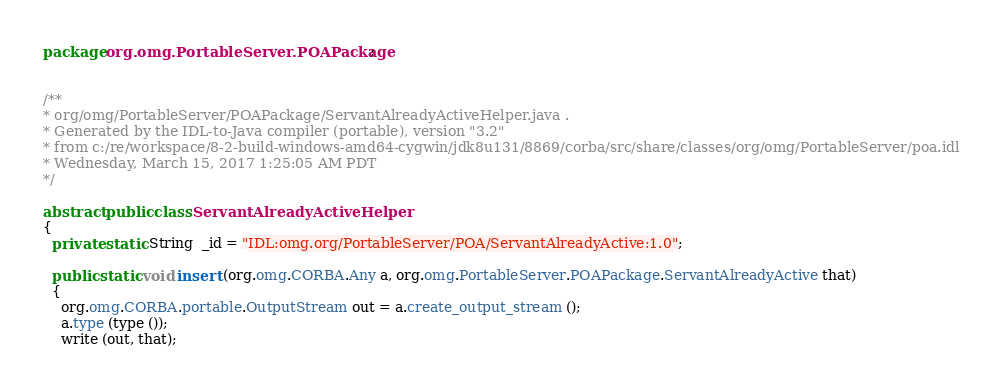Convert code to text. <code><loc_0><loc_0><loc_500><loc_500><_Java_>package org.omg.PortableServer.POAPackage;


/**
* org/omg/PortableServer/POAPackage/ServantAlreadyActiveHelper.java .
* Generated by the IDL-to-Java compiler (portable), version "3.2"
* from c:/re/workspace/8-2-build-windows-amd64-cygwin/jdk8u131/8869/corba/src/share/classes/org/omg/PortableServer/poa.idl
* Wednesday, March 15, 2017 1:25:05 AM PDT
*/

abstract public class ServantAlreadyActiveHelper
{
  private static String  _id = "IDL:omg.org/PortableServer/POA/ServantAlreadyActive:1.0";

  public static void insert (org.omg.CORBA.Any a, org.omg.PortableServer.POAPackage.ServantAlreadyActive that)
  {
    org.omg.CORBA.portable.OutputStream out = a.create_output_stream ();
    a.type (type ());
    write (out, that);</code> 